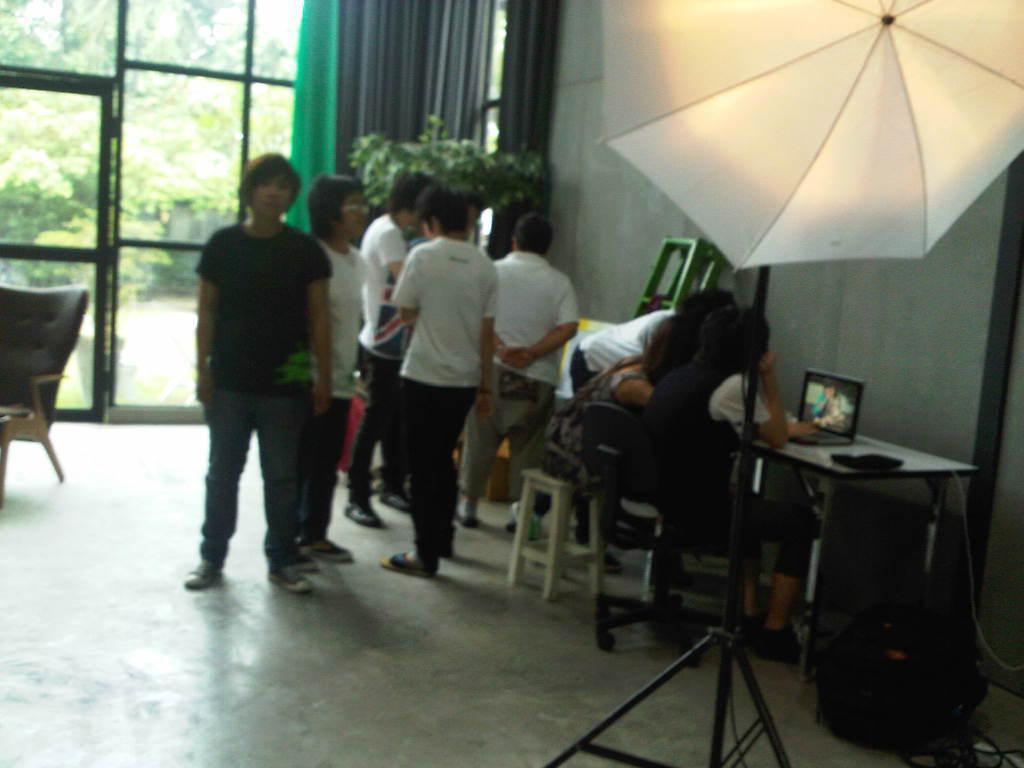Could you give a brief overview of what you see in this image? In this image there are group of people standing, another group of people sitting in chair , and in table there is calculator , laptop and in back ground there are curtain, tree, window, chair, umbrella, stand, planter. 